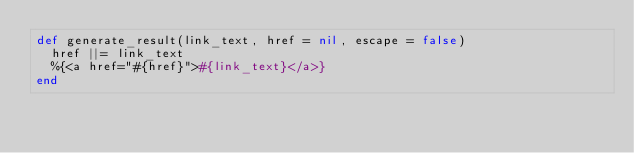Convert code to text. <code><loc_0><loc_0><loc_500><loc_500><_Crystal_>def generate_result(link_text, href = nil, escape = false)
  href ||= link_text
  %{<a href="#{href}">#{link_text}</a>}
end
</code> 